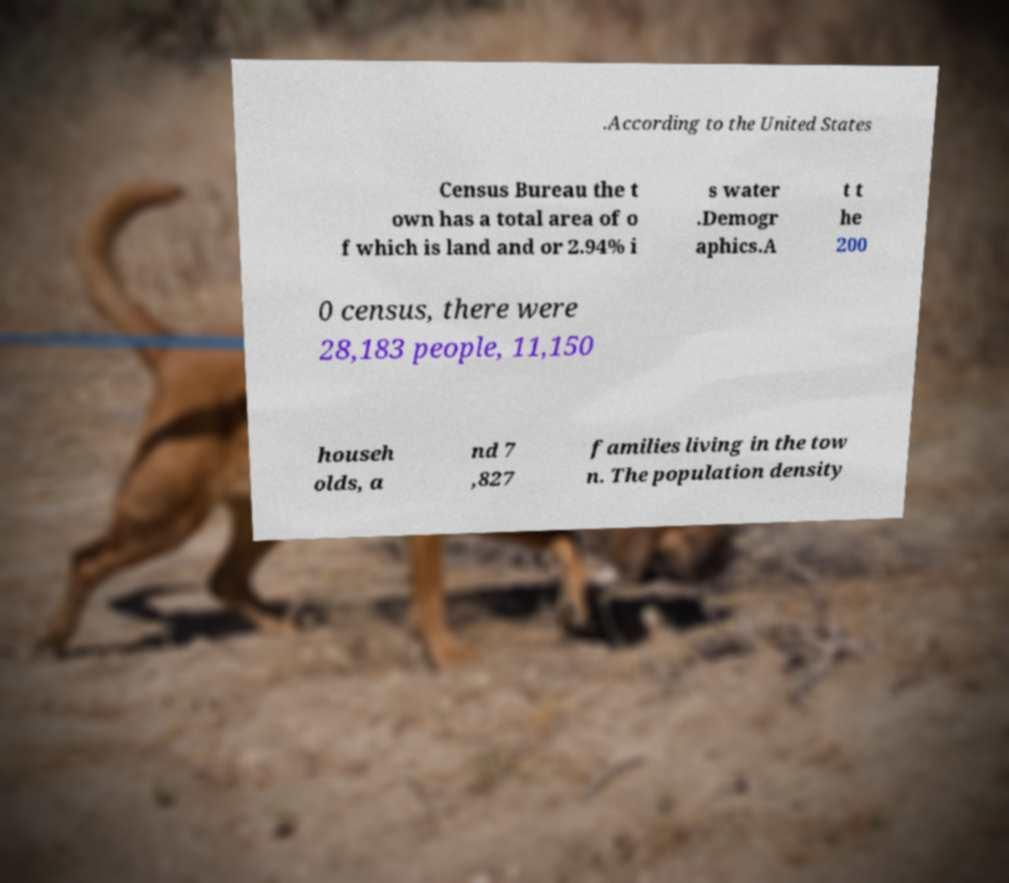Could you extract and type out the text from this image? .According to the United States Census Bureau the t own has a total area of o f which is land and or 2.94% i s water .Demogr aphics.A t t he 200 0 census, there were 28,183 people, 11,150 househ olds, a nd 7 ,827 families living in the tow n. The population density 